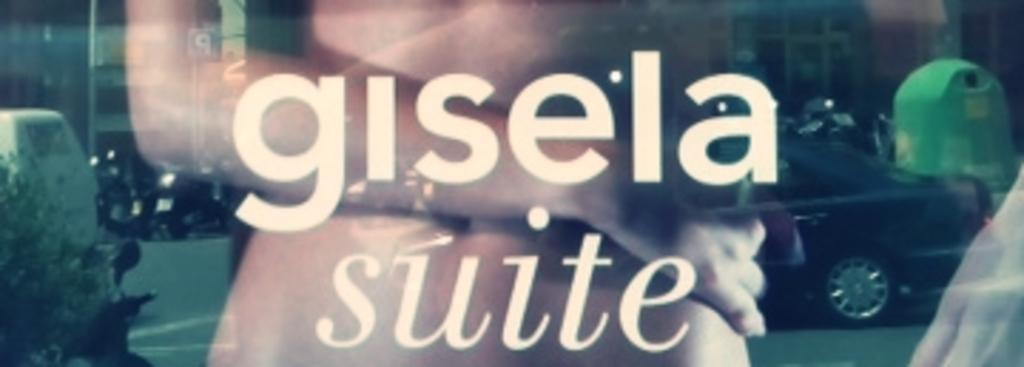What object is present in the image that can hold a liquid? There is a glass in the image. What is written on the glass? Something is written on the glass. Can you describe the background of the image? There is a person, vehicles, and buildings in the background of the image. What type of drug can be seen in the image? There is no drug present in the image. Is the image taken during the winter season? The provided facts do not mention any details about the season or weather, so it cannot be determined if the image was taken during winter. What time of day is the image taken? The provided facts do not mention any details about the time of day, so it cannot be determined if the image was taken in the morning. 